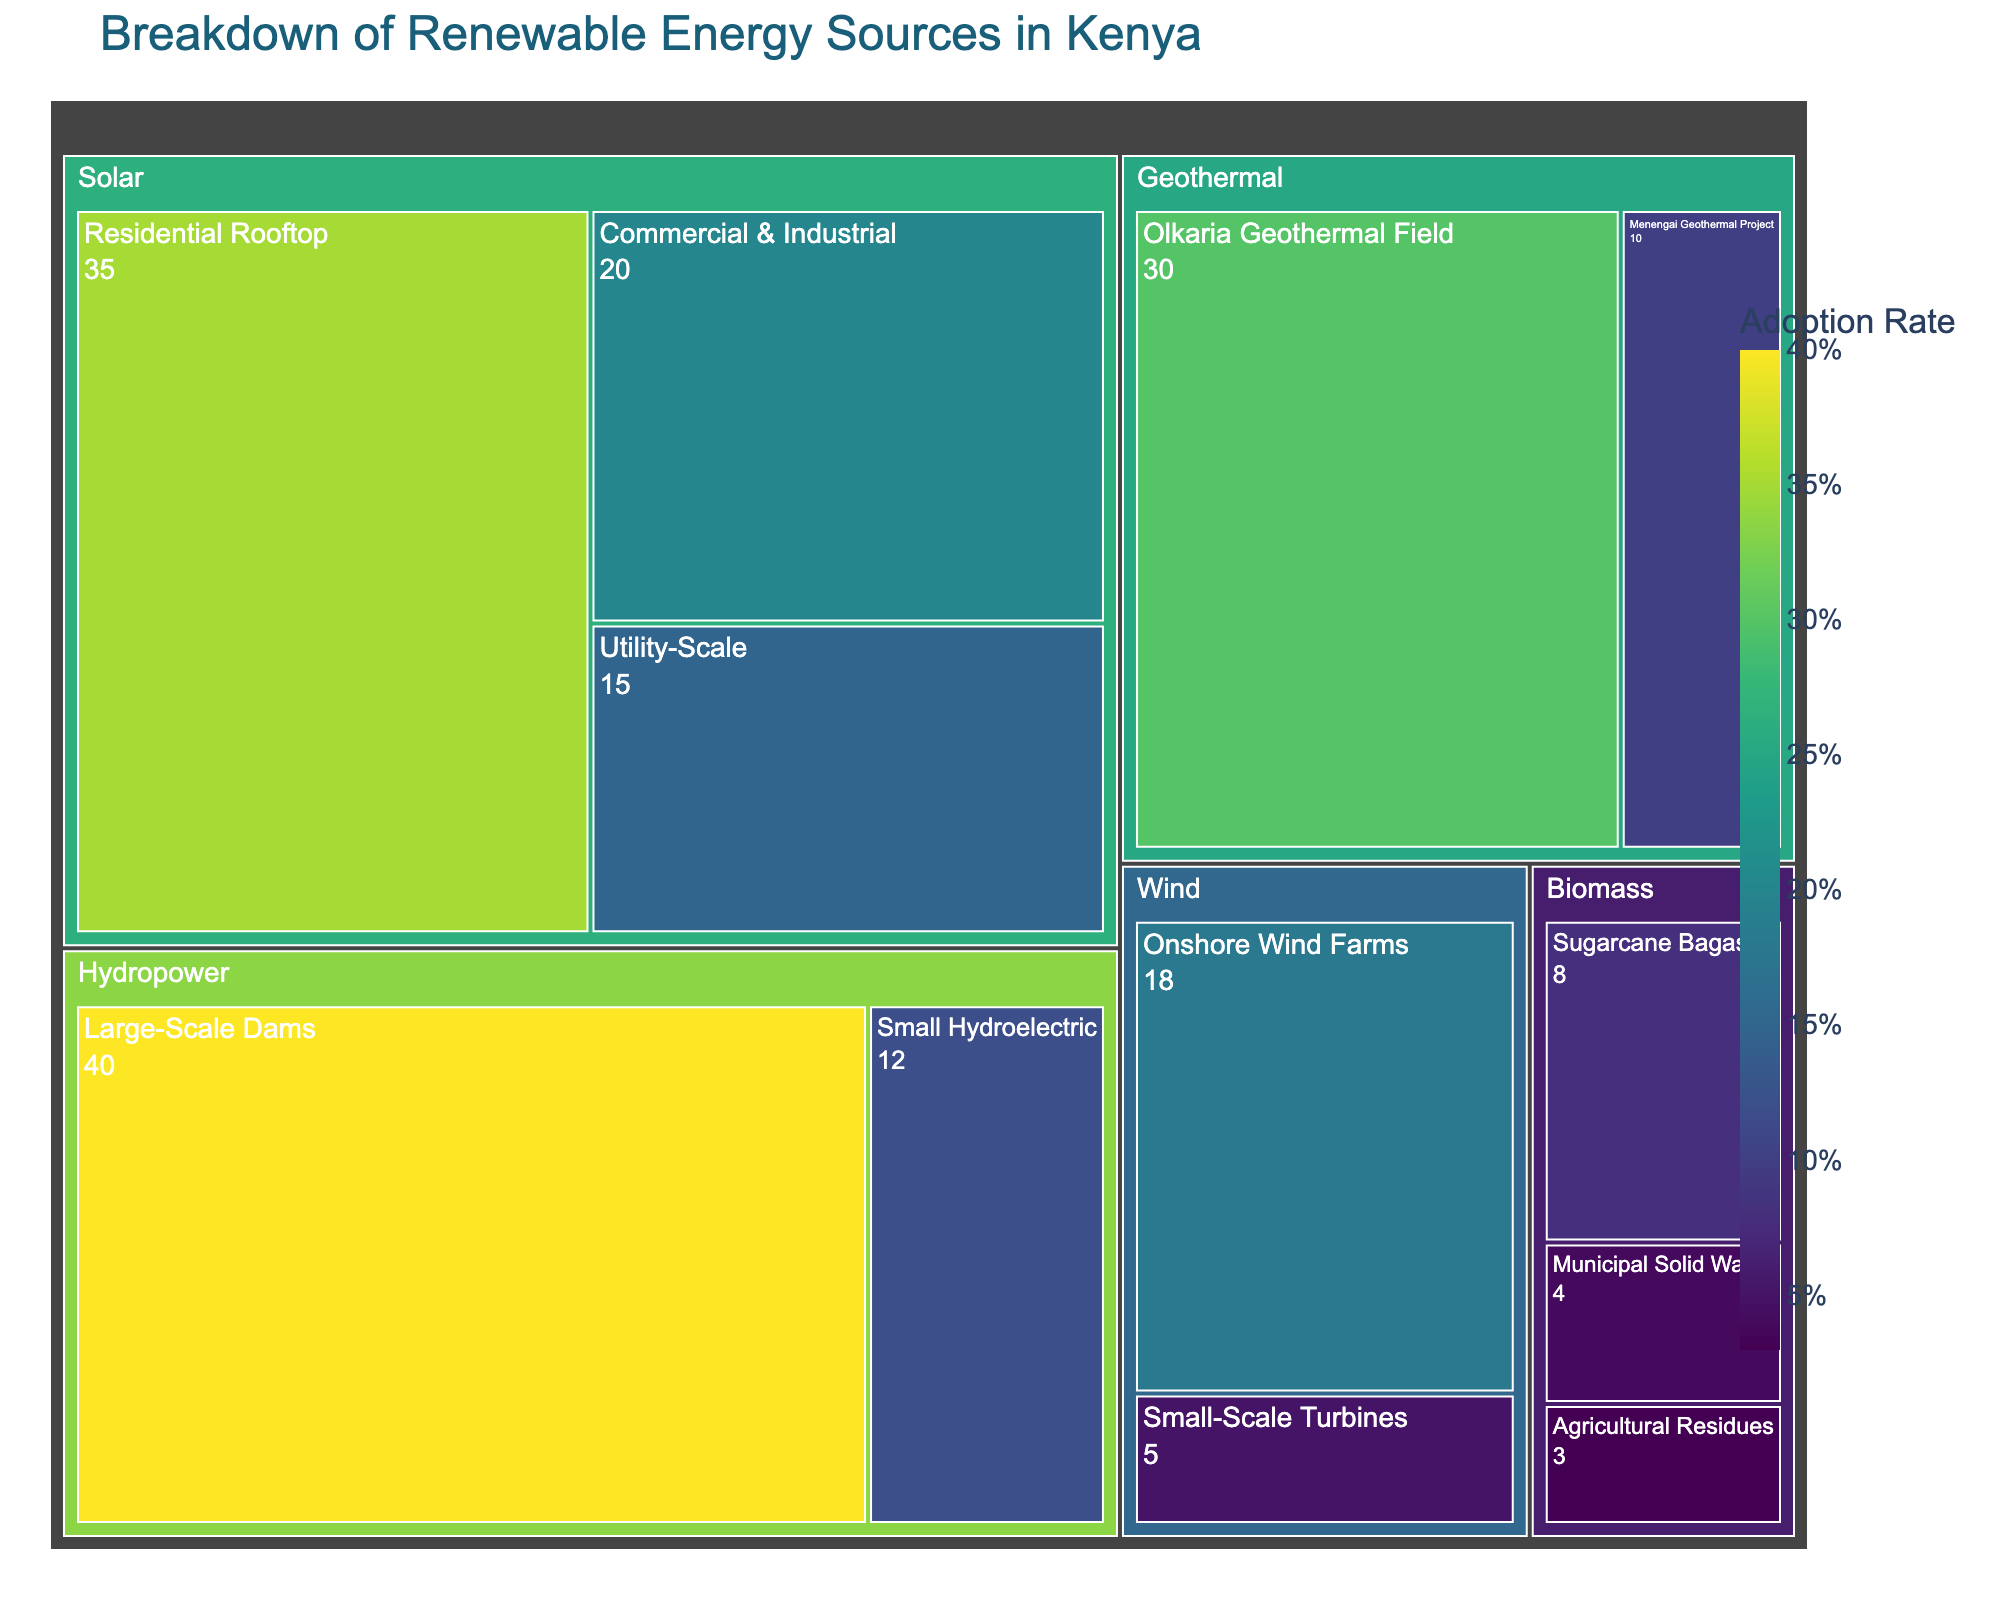What is the title of the treemap? The title is usually displayed prominently at the top of the figure.
Answer: Breakdown of Renewable Energy Sources in Kenya Which renewable energy subcategory has the highest adoption rate? Look for the subcategory with the largest area and the highest percentage value in the treemap.
Answer: Large-Scale Dams How many different categories of renewable energy sources are depicted in the figure? Count the distinct parent categories in the treemap.
Answer: 5 What is the adoption rate of Residential Rooftop Solar? Locate the Solar category in the treemap and find the subcategory for Residential Rooftop.
Answer: 35% What is the combined adoption rate of all Solar energy subcategories? Add the adoption rates of Residential Rooftop, Commercial & Industrial, and Utility-Scale.
Answer: 70% Which has a higher adoption rate, Geothermal or Biomass energy sources? Sum the adoption rates of the subcategories under Geothermal and Biomass, then compare.
Answer: Geothermal Compare the adoption rates of Onshore Wind Farms and Small Hydroelectric. Which one is higher? Locate the Wind and Hydropower categories, then find the respective subcategories and compare their values.
Answer: Onshore Wind Farms Are there more subcategories within the Wind or Biomass category? Count the number of subcategories under each category in the treemap.
Answer: Biomass What is the difference in adoption rate between Large-Scale Dams and Olkaria Geothermal Field? Subtract the adoption rate of Olkaria Geothermal Field from that of Large-Scale Dams.
Answer: 10% Which subcategory within Biomass has the lowest adoption rate? Find the subcategory with the smallest value within the Biomass category.
Answer: Agricultural Residues 